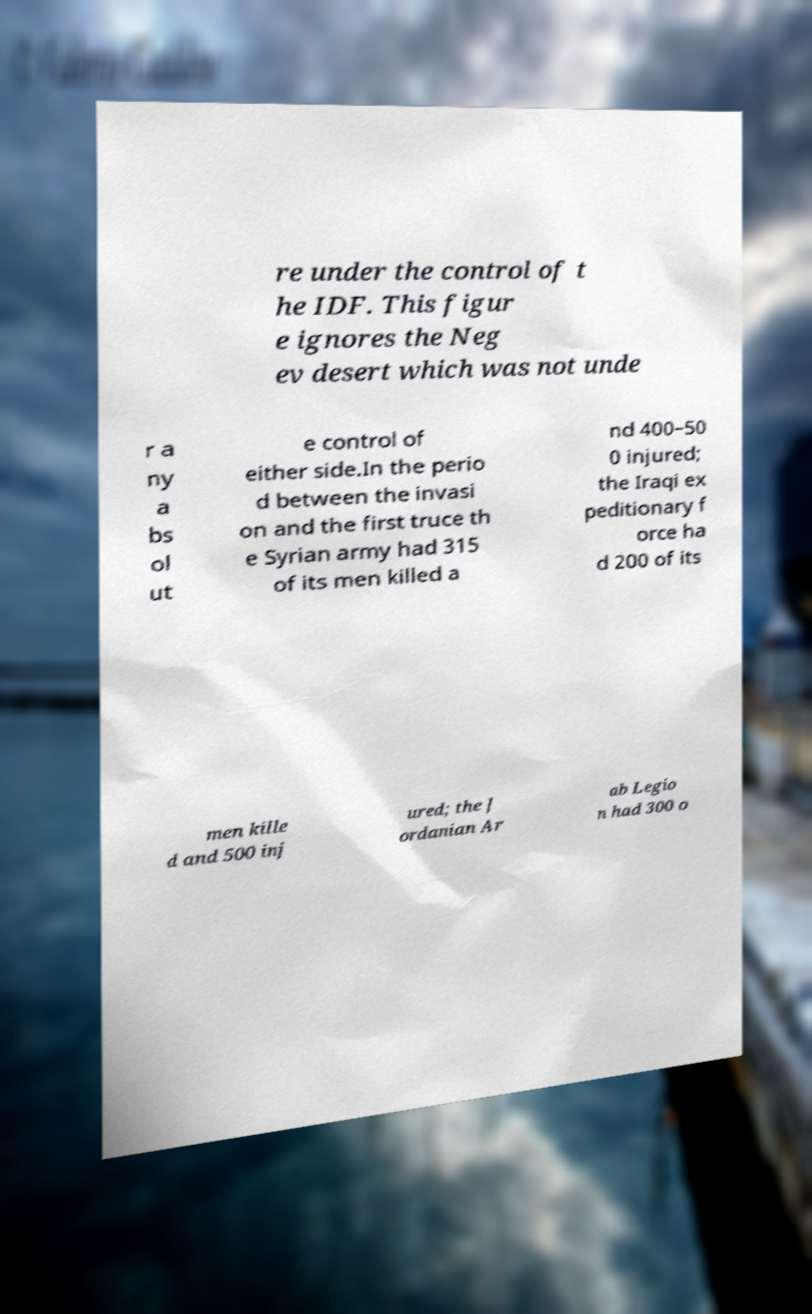Can you read and provide the text displayed in the image?This photo seems to have some interesting text. Can you extract and type it out for me? re under the control of t he IDF. This figur e ignores the Neg ev desert which was not unde r a ny a bs ol ut e control of either side.In the perio d between the invasi on and the first truce th e Syrian army had 315 of its men killed a nd 400–50 0 injured; the Iraqi ex peditionary f orce ha d 200 of its men kille d and 500 inj ured; the J ordanian Ar ab Legio n had 300 o 